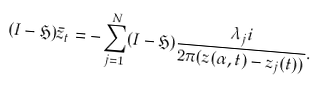Convert formula to latex. <formula><loc_0><loc_0><loc_500><loc_500>( I - \mathfrak { H } ) \bar { z } _ { t } = - \sum _ { j = 1 } ^ { N } ( I - \mathfrak { H } ) \frac { \lambda _ { j } i } { 2 \pi ( z ( \alpha , t ) - z _ { j } ( t ) ) } .</formula> 